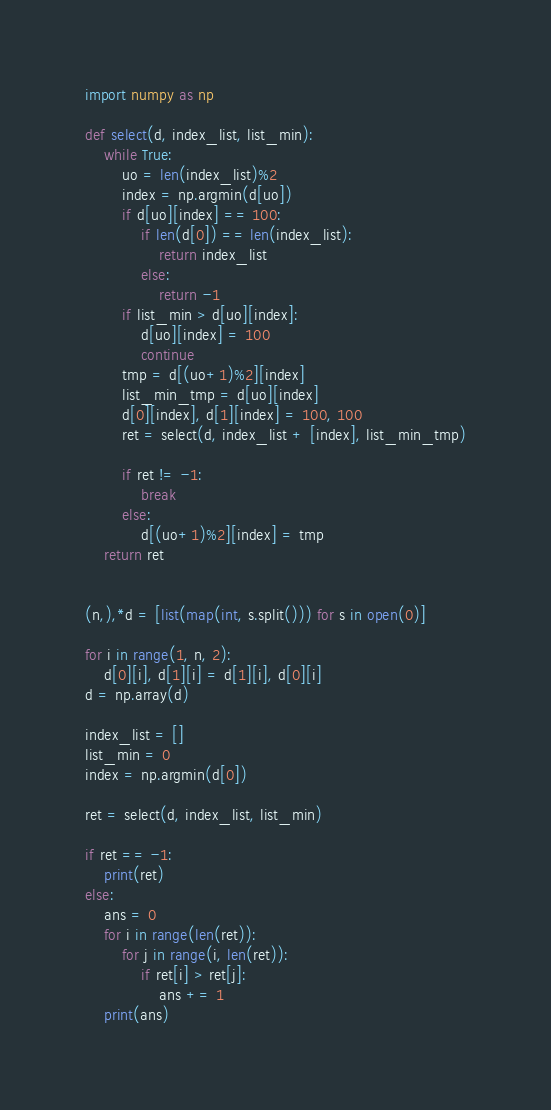Convert code to text. <code><loc_0><loc_0><loc_500><loc_500><_Python_>import numpy as np

def select(d, index_list, list_min):
    while True:
        uo = len(index_list)%2
        index = np.argmin(d[uo])
        if d[uo][index] == 100:
            if len(d[0]) == len(index_list):
                return index_list
            else:
                return -1
        if list_min > d[uo][index]:
            d[uo][index] = 100
            continue
        tmp = d[(uo+1)%2][index]
        list_min_tmp = d[uo][index]
        d[0][index], d[1][index] = 100, 100
        ret = select(d, index_list + [index], list_min_tmp)

        if ret != -1:
            break
        else:
            d[(uo+1)%2][index] = tmp
    return ret
        

(n,),*d = [list(map(int, s.split())) for s in open(0)]

for i in range(1, n, 2):
    d[0][i], d[1][i] = d[1][i], d[0][i]
d = np.array(d)

index_list = []
list_min = 0
index = np.argmin(d[0])

ret = select(d, index_list, list_min)

if ret == -1:
    print(ret)
else:
    ans = 0
    for i in range(len(ret)):
        for j in range(i, len(ret)):
            if ret[i] > ret[j]:
                ans += 1
    print(ans)</code> 